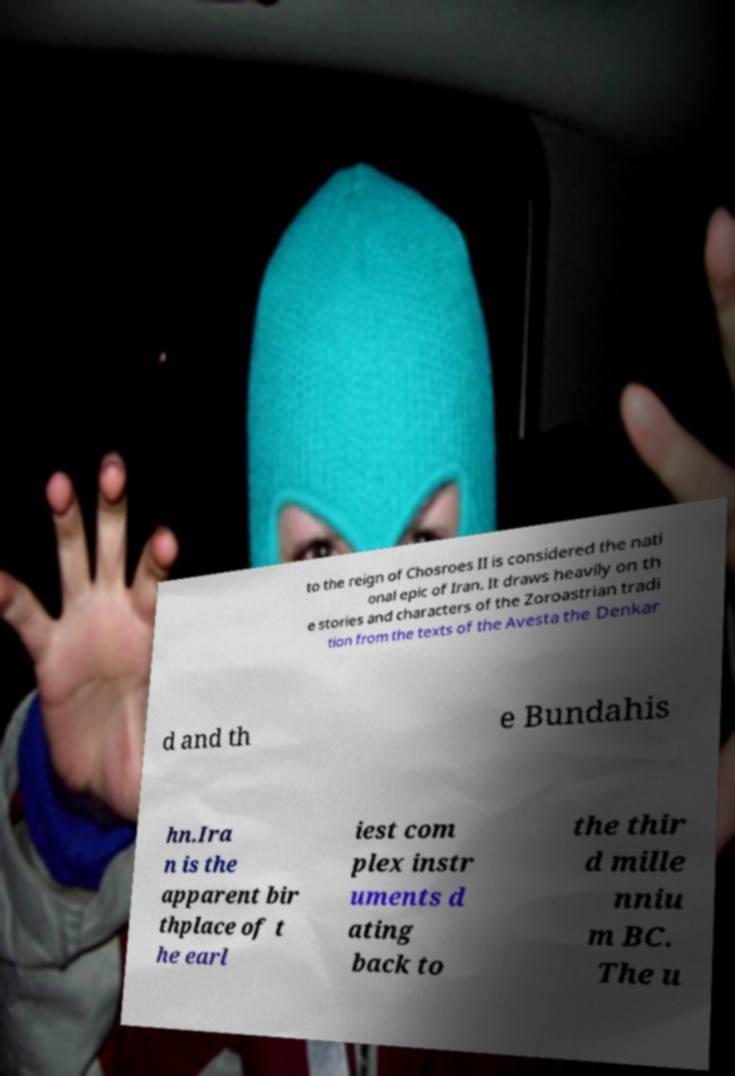Can you accurately transcribe the text from the provided image for me? to the reign of Chosroes II is considered the nati onal epic of Iran. It draws heavily on th e stories and characters of the Zoroastrian tradi tion from the texts of the Avesta the Denkar d and th e Bundahis hn.Ira n is the apparent bir thplace of t he earl iest com plex instr uments d ating back to the thir d mille nniu m BC. The u 